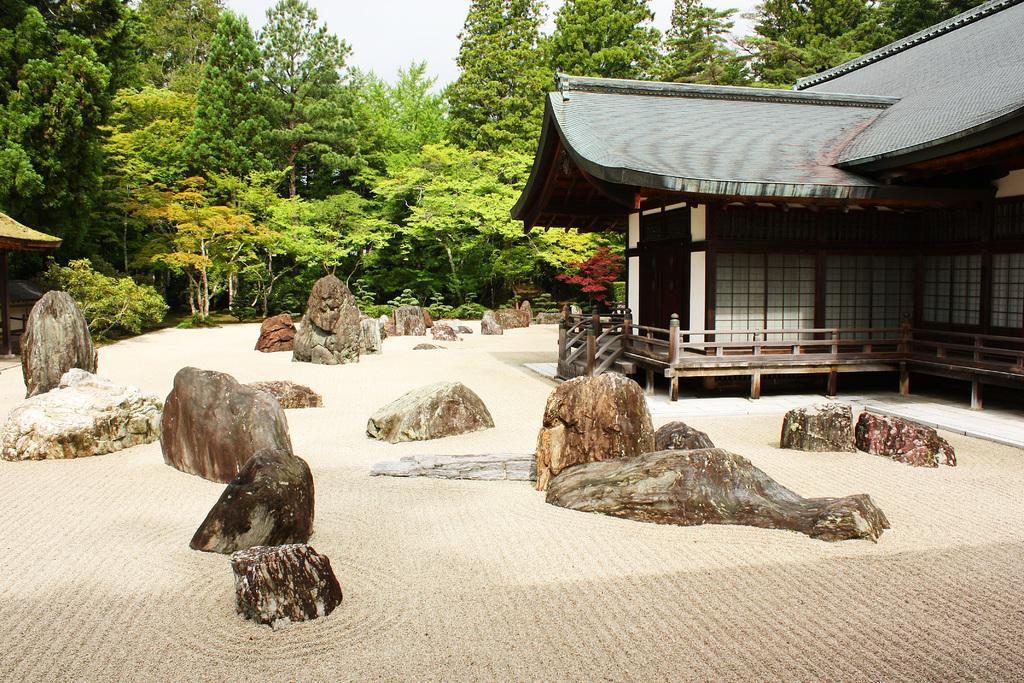Describe this image in one or two sentences. In this picture there is a house towards the right. Before it there are stones. In the background there are trees and sky. 